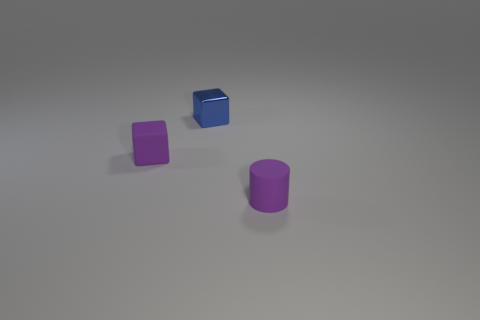There is a small rubber object that is the same color as the small cylinder; what shape is it?
Offer a terse response. Cube. There is a small cylinder; is it the same color as the tiny matte object that is on the left side of the blue block?
Offer a very short reply. Yes. The cube that is the same color as the tiny rubber cylinder is what size?
Your response must be concise. Small. How many other objects are the same shape as the metallic object?
Make the answer very short. 1. What shape is the thing that is both in front of the tiny metal block and to the left of the tiny purple cylinder?
Provide a short and direct response. Cube. Are there any tiny things in front of the tiny matte block?
Offer a very short reply. Yes. There is a purple matte thing that is the same shape as the blue metal object; what is its size?
Your answer should be compact. Small. What size is the matte thing left of the small purple matte object right of the small purple rubber cube?
Provide a succinct answer. Small. There is another small object that is the same shape as the tiny metal thing; what is its color?
Make the answer very short. Purple. How many tiny matte cylinders are the same color as the matte block?
Give a very brief answer. 1. 